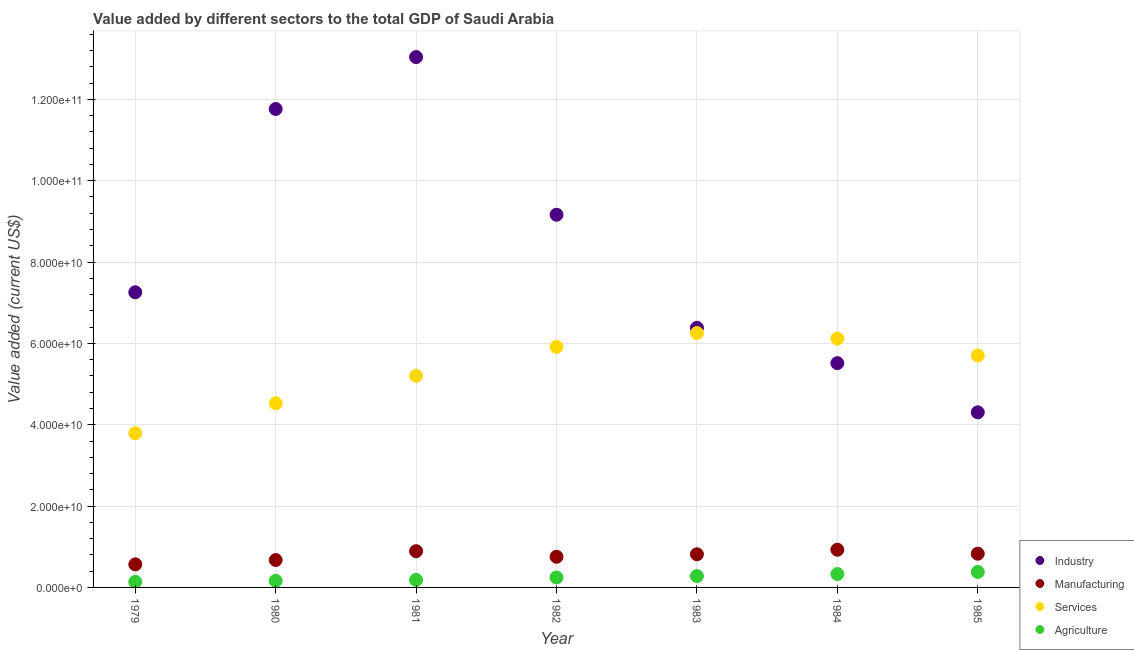What is the value added by industrial sector in 1983?
Give a very brief answer. 6.38e+1. Across all years, what is the maximum value added by industrial sector?
Keep it short and to the point. 1.30e+11. Across all years, what is the minimum value added by manufacturing sector?
Provide a succinct answer. 5.67e+09. In which year was the value added by industrial sector minimum?
Offer a very short reply. 1985. What is the total value added by industrial sector in the graph?
Your answer should be compact. 5.74e+11. What is the difference between the value added by manufacturing sector in 1984 and that in 1985?
Make the answer very short. 9.83e+08. What is the difference between the value added by services sector in 1982 and the value added by industrial sector in 1984?
Ensure brevity in your answer.  4.02e+09. What is the average value added by agricultural sector per year?
Provide a short and direct response. 2.45e+09. In the year 1982, what is the difference between the value added by manufacturing sector and value added by services sector?
Give a very brief answer. -5.16e+1. What is the ratio of the value added by agricultural sector in 1981 to that in 1983?
Keep it short and to the point. 0.66. Is the difference between the value added by manufacturing sector in 1982 and 1985 greater than the difference between the value added by industrial sector in 1982 and 1985?
Offer a terse response. No. What is the difference between the highest and the second highest value added by services sector?
Your answer should be compact. 1.36e+09. What is the difference between the highest and the lowest value added by manufacturing sector?
Make the answer very short. 3.60e+09. Is the sum of the value added by agricultural sector in 1979 and 1981 greater than the maximum value added by services sector across all years?
Your answer should be very brief. No. Is the value added by industrial sector strictly greater than the value added by manufacturing sector over the years?
Offer a terse response. Yes. Is the value added by agricultural sector strictly less than the value added by industrial sector over the years?
Your answer should be compact. Yes. How many years are there in the graph?
Offer a terse response. 7. Does the graph contain any zero values?
Ensure brevity in your answer.  No. Where does the legend appear in the graph?
Provide a short and direct response. Bottom right. How are the legend labels stacked?
Give a very brief answer. Vertical. What is the title of the graph?
Make the answer very short. Value added by different sectors to the total GDP of Saudi Arabia. Does "Ease of arranging shipments" appear as one of the legend labels in the graph?
Ensure brevity in your answer.  No. What is the label or title of the Y-axis?
Give a very brief answer. Value added (current US$). What is the Value added (current US$) of Industry in 1979?
Offer a terse response. 7.26e+1. What is the Value added (current US$) of Manufacturing in 1979?
Provide a succinct answer. 5.67e+09. What is the Value added (current US$) of Services in 1979?
Give a very brief answer. 3.79e+1. What is the Value added (current US$) of Agriculture in 1979?
Ensure brevity in your answer.  1.37e+09. What is the Value added (current US$) in Industry in 1980?
Your answer should be very brief. 1.18e+11. What is the Value added (current US$) of Manufacturing in 1980?
Offer a terse response. 6.74e+09. What is the Value added (current US$) in Services in 1980?
Your answer should be very brief. 4.53e+1. What is the Value added (current US$) of Agriculture in 1980?
Offer a terse response. 1.62e+09. What is the Value added (current US$) in Industry in 1981?
Your answer should be compact. 1.30e+11. What is the Value added (current US$) in Manufacturing in 1981?
Offer a terse response. 8.91e+09. What is the Value added (current US$) of Services in 1981?
Offer a terse response. 5.20e+1. What is the Value added (current US$) of Agriculture in 1981?
Give a very brief answer. 1.85e+09. What is the Value added (current US$) of Industry in 1982?
Keep it short and to the point. 9.16e+1. What is the Value added (current US$) in Manufacturing in 1982?
Your response must be concise. 7.54e+09. What is the Value added (current US$) in Services in 1982?
Ensure brevity in your answer.  5.92e+1. What is the Value added (current US$) of Agriculture in 1982?
Make the answer very short. 2.44e+09. What is the Value added (current US$) of Industry in 1983?
Ensure brevity in your answer.  6.38e+1. What is the Value added (current US$) of Manufacturing in 1983?
Your answer should be very brief. 8.15e+09. What is the Value added (current US$) in Services in 1983?
Your answer should be very brief. 6.25e+1. What is the Value added (current US$) in Agriculture in 1983?
Your response must be concise. 2.79e+09. What is the Value added (current US$) of Industry in 1984?
Ensure brevity in your answer.  5.51e+1. What is the Value added (current US$) of Manufacturing in 1984?
Offer a very short reply. 9.27e+09. What is the Value added (current US$) of Services in 1984?
Keep it short and to the point. 6.12e+1. What is the Value added (current US$) in Agriculture in 1984?
Provide a short and direct response. 3.30e+09. What is the Value added (current US$) in Industry in 1985?
Keep it short and to the point. 4.31e+1. What is the Value added (current US$) of Manufacturing in 1985?
Your answer should be compact. 8.29e+09. What is the Value added (current US$) in Services in 1985?
Offer a very short reply. 5.70e+1. What is the Value added (current US$) of Agriculture in 1985?
Your response must be concise. 3.81e+09. Across all years, what is the maximum Value added (current US$) of Industry?
Ensure brevity in your answer.  1.30e+11. Across all years, what is the maximum Value added (current US$) of Manufacturing?
Provide a short and direct response. 9.27e+09. Across all years, what is the maximum Value added (current US$) in Services?
Keep it short and to the point. 6.25e+1. Across all years, what is the maximum Value added (current US$) in Agriculture?
Offer a terse response. 3.81e+09. Across all years, what is the minimum Value added (current US$) of Industry?
Ensure brevity in your answer.  4.31e+1. Across all years, what is the minimum Value added (current US$) in Manufacturing?
Your answer should be very brief. 5.67e+09. Across all years, what is the minimum Value added (current US$) in Services?
Offer a terse response. 3.79e+1. Across all years, what is the minimum Value added (current US$) in Agriculture?
Make the answer very short. 1.37e+09. What is the total Value added (current US$) in Industry in the graph?
Offer a very short reply. 5.74e+11. What is the total Value added (current US$) in Manufacturing in the graph?
Your response must be concise. 5.46e+1. What is the total Value added (current US$) in Services in the graph?
Offer a very short reply. 3.75e+11. What is the total Value added (current US$) of Agriculture in the graph?
Provide a succinct answer. 1.72e+1. What is the difference between the Value added (current US$) in Industry in 1979 and that in 1980?
Provide a short and direct response. -4.51e+1. What is the difference between the Value added (current US$) of Manufacturing in 1979 and that in 1980?
Your response must be concise. -1.06e+09. What is the difference between the Value added (current US$) in Services in 1979 and that in 1980?
Offer a terse response. -7.36e+09. What is the difference between the Value added (current US$) in Agriculture in 1979 and that in 1980?
Offer a terse response. -2.54e+08. What is the difference between the Value added (current US$) of Industry in 1979 and that in 1981?
Your answer should be compact. -5.78e+1. What is the difference between the Value added (current US$) in Manufacturing in 1979 and that in 1981?
Your answer should be very brief. -3.24e+09. What is the difference between the Value added (current US$) of Services in 1979 and that in 1981?
Provide a short and direct response. -1.41e+1. What is the difference between the Value added (current US$) of Agriculture in 1979 and that in 1981?
Make the answer very short. -4.80e+08. What is the difference between the Value added (current US$) of Industry in 1979 and that in 1982?
Your answer should be compact. -1.91e+1. What is the difference between the Value added (current US$) in Manufacturing in 1979 and that in 1982?
Give a very brief answer. -1.86e+09. What is the difference between the Value added (current US$) of Services in 1979 and that in 1982?
Your answer should be very brief. -2.12e+1. What is the difference between the Value added (current US$) in Agriculture in 1979 and that in 1982?
Offer a terse response. -1.07e+09. What is the difference between the Value added (current US$) in Industry in 1979 and that in 1983?
Offer a terse response. 8.74e+09. What is the difference between the Value added (current US$) of Manufacturing in 1979 and that in 1983?
Provide a succinct answer. -2.48e+09. What is the difference between the Value added (current US$) of Services in 1979 and that in 1983?
Provide a succinct answer. -2.46e+1. What is the difference between the Value added (current US$) of Agriculture in 1979 and that in 1983?
Your answer should be compact. -1.42e+09. What is the difference between the Value added (current US$) in Industry in 1979 and that in 1984?
Provide a short and direct response. 1.74e+1. What is the difference between the Value added (current US$) of Manufacturing in 1979 and that in 1984?
Keep it short and to the point. -3.60e+09. What is the difference between the Value added (current US$) of Services in 1979 and that in 1984?
Ensure brevity in your answer.  -2.33e+1. What is the difference between the Value added (current US$) of Agriculture in 1979 and that in 1984?
Make the answer very short. -1.93e+09. What is the difference between the Value added (current US$) of Industry in 1979 and that in 1985?
Provide a short and direct response. 2.95e+1. What is the difference between the Value added (current US$) in Manufacturing in 1979 and that in 1985?
Provide a succinct answer. -2.62e+09. What is the difference between the Value added (current US$) in Services in 1979 and that in 1985?
Give a very brief answer. -1.91e+1. What is the difference between the Value added (current US$) in Agriculture in 1979 and that in 1985?
Make the answer very short. -2.44e+09. What is the difference between the Value added (current US$) of Industry in 1980 and that in 1981?
Provide a succinct answer. -1.28e+1. What is the difference between the Value added (current US$) in Manufacturing in 1980 and that in 1981?
Your answer should be compact. -2.18e+09. What is the difference between the Value added (current US$) in Services in 1980 and that in 1981?
Your answer should be very brief. -6.76e+09. What is the difference between the Value added (current US$) of Agriculture in 1980 and that in 1981?
Offer a very short reply. -2.26e+08. What is the difference between the Value added (current US$) in Industry in 1980 and that in 1982?
Provide a short and direct response. 2.60e+1. What is the difference between the Value added (current US$) in Manufacturing in 1980 and that in 1982?
Keep it short and to the point. -8.01e+08. What is the difference between the Value added (current US$) of Services in 1980 and that in 1982?
Keep it short and to the point. -1.39e+1. What is the difference between the Value added (current US$) of Agriculture in 1980 and that in 1982?
Make the answer very short. -8.19e+08. What is the difference between the Value added (current US$) in Industry in 1980 and that in 1983?
Your answer should be compact. 5.38e+1. What is the difference between the Value added (current US$) of Manufacturing in 1980 and that in 1983?
Your answer should be very brief. -1.41e+09. What is the difference between the Value added (current US$) of Services in 1980 and that in 1983?
Provide a short and direct response. -1.73e+1. What is the difference between the Value added (current US$) in Agriculture in 1980 and that in 1983?
Provide a succinct answer. -1.17e+09. What is the difference between the Value added (current US$) of Industry in 1980 and that in 1984?
Make the answer very short. 6.25e+1. What is the difference between the Value added (current US$) in Manufacturing in 1980 and that in 1984?
Your response must be concise. -2.54e+09. What is the difference between the Value added (current US$) in Services in 1980 and that in 1984?
Your answer should be compact. -1.59e+1. What is the difference between the Value added (current US$) in Agriculture in 1980 and that in 1984?
Offer a very short reply. -1.67e+09. What is the difference between the Value added (current US$) of Industry in 1980 and that in 1985?
Your answer should be very brief. 7.46e+1. What is the difference between the Value added (current US$) in Manufacturing in 1980 and that in 1985?
Offer a terse response. -1.55e+09. What is the difference between the Value added (current US$) of Services in 1980 and that in 1985?
Your response must be concise. -1.18e+1. What is the difference between the Value added (current US$) of Agriculture in 1980 and that in 1985?
Provide a short and direct response. -2.18e+09. What is the difference between the Value added (current US$) of Industry in 1981 and that in 1982?
Provide a succinct answer. 3.88e+1. What is the difference between the Value added (current US$) in Manufacturing in 1981 and that in 1982?
Your answer should be compact. 1.38e+09. What is the difference between the Value added (current US$) in Services in 1981 and that in 1982?
Your answer should be compact. -7.12e+09. What is the difference between the Value added (current US$) in Agriculture in 1981 and that in 1982?
Provide a short and direct response. -5.93e+08. What is the difference between the Value added (current US$) of Industry in 1981 and that in 1983?
Your response must be concise. 6.66e+1. What is the difference between the Value added (current US$) of Manufacturing in 1981 and that in 1983?
Give a very brief answer. 7.62e+08. What is the difference between the Value added (current US$) in Services in 1981 and that in 1983?
Offer a terse response. -1.05e+1. What is the difference between the Value added (current US$) of Agriculture in 1981 and that in 1983?
Your answer should be very brief. -9.42e+08. What is the difference between the Value added (current US$) in Industry in 1981 and that in 1984?
Provide a short and direct response. 7.53e+1. What is the difference between the Value added (current US$) of Manufacturing in 1981 and that in 1984?
Your answer should be very brief. -3.60e+08. What is the difference between the Value added (current US$) of Services in 1981 and that in 1984?
Your answer should be very brief. -9.14e+09. What is the difference between the Value added (current US$) of Agriculture in 1981 and that in 1984?
Your response must be concise. -1.45e+09. What is the difference between the Value added (current US$) of Industry in 1981 and that in 1985?
Offer a very short reply. 8.73e+1. What is the difference between the Value added (current US$) of Manufacturing in 1981 and that in 1985?
Offer a terse response. 6.23e+08. What is the difference between the Value added (current US$) in Services in 1981 and that in 1985?
Your answer should be compact. -5.00e+09. What is the difference between the Value added (current US$) in Agriculture in 1981 and that in 1985?
Offer a very short reply. -1.96e+09. What is the difference between the Value added (current US$) of Industry in 1982 and that in 1983?
Your answer should be compact. 2.78e+1. What is the difference between the Value added (current US$) in Manufacturing in 1982 and that in 1983?
Provide a succinct answer. -6.13e+08. What is the difference between the Value added (current US$) of Services in 1982 and that in 1983?
Offer a very short reply. -3.38e+09. What is the difference between the Value added (current US$) of Agriculture in 1982 and that in 1983?
Provide a short and direct response. -3.49e+08. What is the difference between the Value added (current US$) in Industry in 1982 and that in 1984?
Make the answer very short. 3.65e+1. What is the difference between the Value added (current US$) of Manufacturing in 1982 and that in 1984?
Keep it short and to the point. -1.74e+09. What is the difference between the Value added (current US$) in Services in 1982 and that in 1984?
Ensure brevity in your answer.  -2.02e+09. What is the difference between the Value added (current US$) of Agriculture in 1982 and that in 1984?
Offer a terse response. -8.55e+08. What is the difference between the Value added (current US$) in Industry in 1982 and that in 1985?
Provide a succinct answer. 4.86e+1. What is the difference between the Value added (current US$) in Manufacturing in 1982 and that in 1985?
Provide a short and direct response. -7.53e+08. What is the difference between the Value added (current US$) of Services in 1982 and that in 1985?
Make the answer very short. 2.13e+09. What is the difference between the Value added (current US$) of Agriculture in 1982 and that in 1985?
Your answer should be very brief. -1.36e+09. What is the difference between the Value added (current US$) of Industry in 1983 and that in 1984?
Your answer should be very brief. 8.69e+09. What is the difference between the Value added (current US$) of Manufacturing in 1983 and that in 1984?
Offer a terse response. -1.12e+09. What is the difference between the Value added (current US$) in Services in 1983 and that in 1984?
Provide a succinct answer. 1.36e+09. What is the difference between the Value added (current US$) in Agriculture in 1983 and that in 1984?
Your response must be concise. -5.06e+08. What is the difference between the Value added (current US$) in Industry in 1983 and that in 1985?
Provide a succinct answer. 2.08e+1. What is the difference between the Value added (current US$) of Manufacturing in 1983 and that in 1985?
Provide a short and direct response. -1.40e+08. What is the difference between the Value added (current US$) of Services in 1983 and that in 1985?
Give a very brief answer. 5.51e+09. What is the difference between the Value added (current US$) in Agriculture in 1983 and that in 1985?
Offer a terse response. -1.02e+09. What is the difference between the Value added (current US$) of Industry in 1984 and that in 1985?
Make the answer very short. 1.21e+1. What is the difference between the Value added (current US$) of Manufacturing in 1984 and that in 1985?
Offer a terse response. 9.83e+08. What is the difference between the Value added (current US$) of Services in 1984 and that in 1985?
Your answer should be very brief. 4.14e+09. What is the difference between the Value added (current US$) of Agriculture in 1984 and that in 1985?
Make the answer very short. -5.10e+08. What is the difference between the Value added (current US$) of Industry in 1979 and the Value added (current US$) of Manufacturing in 1980?
Provide a succinct answer. 6.58e+1. What is the difference between the Value added (current US$) in Industry in 1979 and the Value added (current US$) in Services in 1980?
Your response must be concise. 2.73e+1. What is the difference between the Value added (current US$) of Industry in 1979 and the Value added (current US$) of Agriculture in 1980?
Your answer should be compact. 7.10e+1. What is the difference between the Value added (current US$) of Manufacturing in 1979 and the Value added (current US$) of Services in 1980?
Provide a short and direct response. -3.96e+1. What is the difference between the Value added (current US$) in Manufacturing in 1979 and the Value added (current US$) in Agriculture in 1980?
Your answer should be compact. 4.05e+09. What is the difference between the Value added (current US$) of Services in 1979 and the Value added (current US$) of Agriculture in 1980?
Your response must be concise. 3.63e+1. What is the difference between the Value added (current US$) in Industry in 1979 and the Value added (current US$) in Manufacturing in 1981?
Provide a succinct answer. 6.37e+1. What is the difference between the Value added (current US$) in Industry in 1979 and the Value added (current US$) in Services in 1981?
Keep it short and to the point. 2.05e+1. What is the difference between the Value added (current US$) of Industry in 1979 and the Value added (current US$) of Agriculture in 1981?
Offer a very short reply. 7.07e+1. What is the difference between the Value added (current US$) of Manufacturing in 1979 and the Value added (current US$) of Services in 1981?
Keep it short and to the point. -4.64e+1. What is the difference between the Value added (current US$) of Manufacturing in 1979 and the Value added (current US$) of Agriculture in 1981?
Provide a short and direct response. 3.82e+09. What is the difference between the Value added (current US$) of Services in 1979 and the Value added (current US$) of Agriculture in 1981?
Offer a terse response. 3.61e+1. What is the difference between the Value added (current US$) in Industry in 1979 and the Value added (current US$) in Manufacturing in 1982?
Keep it short and to the point. 6.50e+1. What is the difference between the Value added (current US$) in Industry in 1979 and the Value added (current US$) in Services in 1982?
Your response must be concise. 1.34e+1. What is the difference between the Value added (current US$) in Industry in 1979 and the Value added (current US$) in Agriculture in 1982?
Make the answer very short. 7.01e+1. What is the difference between the Value added (current US$) in Manufacturing in 1979 and the Value added (current US$) in Services in 1982?
Offer a very short reply. -5.35e+1. What is the difference between the Value added (current US$) in Manufacturing in 1979 and the Value added (current US$) in Agriculture in 1982?
Make the answer very short. 3.23e+09. What is the difference between the Value added (current US$) in Services in 1979 and the Value added (current US$) in Agriculture in 1982?
Offer a very short reply. 3.55e+1. What is the difference between the Value added (current US$) of Industry in 1979 and the Value added (current US$) of Manufacturing in 1983?
Offer a very short reply. 6.44e+1. What is the difference between the Value added (current US$) in Industry in 1979 and the Value added (current US$) in Services in 1983?
Offer a terse response. 1.00e+1. What is the difference between the Value added (current US$) of Industry in 1979 and the Value added (current US$) of Agriculture in 1983?
Ensure brevity in your answer.  6.98e+1. What is the difference between the Value added (current US$) in Manufacturing in 1979 and the Value added (current US$) in Services in 1983?
Keep it short and to the point. -5.69e+1. What is the difference between the Value added (current US$) in Manufacturing in 1979 and the Value added (current US$) in Agriculture in 1983?
Your answer should be very brief. 2.88e+09. What is the difference between the Value added (current US$) in Services in 1979 and the Value added (current US$) in Agriculture in 1983?
Provide a short and direct response. 3.51e+1. What is the difference between the Value added (current US$) of Industry in 1979 and the Value added (current US$) of Manufacturing in 1984?
Your answer should be compact. 6.33e+1. What is the difference between the Value added (current US$) in Industry in 1979 and the Value added (current US$) in Services in 1984?
Offer a very short reply. 1.14e+1. What is the difference between the Value added (current US$) of Industry in 1979 and the Value added (current US$) of Agriculture in 1984?
Ensure brevity in your answer.  6.93e+1. What is the difference between the Value added (current US$) of Manufacturing in 1979 and the Value added (current US$) of Services in 1984?
Keep it short and to the point. -5.55e+1. What is the difference between the Value added (current US$) of Manufacturing in 1979 and the Value added (current US$) of Agriculture in 1984?
Ensure brevity in your answer.  2.38e+09. What is the difference between the Value added (current US$) of Services in 1979 and the Value added (current US$) of Agriculture in 1984?
Give a very brief answer. 3.46e+1. What is the difference between the Value added (current US$) of Industry in 1979 and the Value added (current US$) of Manufacturing in 1985?
Keep it short and to the point. 6.43e+1. What is the difference between the Value added (current US$) of Industry in 1979 and the Value added (current US$) of Services in 1985?
Provide a short and direct response. 1.55e+1. What is the difference between the Value added (current US$) in Industry in 1979 and the Value added (current US$) in Agriculture in 1985?
Offer a terse response. 6.88e+1. What is the difference between the Value added (current US$) of Manufacturing in 1979 and the Value added (current US$) of Services in 1985?
Ensure brevity in your answer.  -5.14e+1. What is the difference between the Value added (current US$) of Manufacturing in 1979 and the Value added (current US$) of Agriculture in 1985?
Your answer should be very brief. 1.87e+09. What is the difference between the Value added (current US$) of Services in 1979 and the Value added (current US$) of Agriculture in 1985?
Your response must be concise. 3.41e+1. What is the difference between the Value added (current US$) of Industry in 1980 and the Value added (current US$) of Manufacturing in 1981?
Offer a terse response. 1.09e+11. What is the difference between the Value added (current US$) in Industry in 1980 and the Value added (current US$) in Services in 1981?
Your answer should be compact. 6.56e+1. What is the difference between the Value added (current US$) in Industry in 1980 and the Value added (current US$) in Agriculture in 1981?
Your response must be concise. 1.16e+11. What is the difference between the Value added (current US$) in Manufacturing in 1980 and the Value added (current US$) in Services in 1981?
Make the answer very short. -4.53e+1. What is the difference between the Value added (current US$) in Manufacturing in 1980 and the Value added (current US$) in Agriculture in 1981?
Give a very brief answer. 4.89e+09. What is the difference between the Value added (current US$) in Services in 1980 and the Value added (current US$) in Agriculture in 1981?
Provide a short and direct response. 4.34e+1. What is the difference between the Value added (current US$) of Industry in 1980 and the Value added (current US$) of Manufacturing in 1982?
Keep it short and to the point. 1.10e+11. What is the difference between the Value added (current US$) in Industry in 1980 and the Value added (current US$) in Services in 1982?
Your answer should be compact. 5.85e+1. What is the difference between the Value added (current US$) of Industry in 1980 and the Value added (current US$) of Agriculture in 1982?
Offer a terse response. 1.15e+11. What is the difference between the Value added (current US$) of Manufacturing in 1980 and the Value added (current US$) of Services in 1982?
Provide a succinct answer. -5.24e+1. What is the difference between the Value added (current US$) of Manufacturing in 1980 and the Value added (current US$) of Agriculture in 1982?
Your answer should be very brief. 4.29e+09. What is the difference between the Value added (current US$) of Services in 1980 and the Value added (current US$) of Agriculture in 1982?
Your response must be concise. 4.28e+1. What is the difference between the Value added (current US$) of Industry in 1980 and the Value added (current US$) of Manufacturing in 1983?
Your answer should be compact. 1.09e+11. What is the difference between the Value added (current US$) in Industry in 1980 and the Value added (current US$) in Services in 1983?
Your response must be concise. 5.51e+1. What is the difference between the Value added (current US$) in Industry in 1980 and the Value added (current US$) in Agriculture in 1983?
Offer a very short reply. 1.15e+11. What is the difference between the Value added (current US$) in Manufacturing in 1980 and the Value added (current US$) in Services in 1983?
Make the answer very short. -5.58e+1. What is the difference between the Value added (current US$) in Manufacturing in 1980 and the Value added (current US$) in Agriculture in 1983?
Give a very brief answer. 3.95e+09. What is the difference between the Value added (current US$) of Services in 1980 and the Value added (current US$) of Agriculture in 1983?
Provide a short and direct response. 4.25e+1. What is the difference between the Value added (current US$) of Industry in 1980 and the Value added (current US$) of Manufacturing in 1984?
Provide a succinct answer. 1.08e+11. What is the difference between the Value added (current US$) in Industry in 1980 and the Value added (current US$) in Services in 1984?
Provide a succinct answer. 5.65e+1. What is the difference between the Value added (current US$) of Industry in 1980 and the Value added (current US$) of Agriculture in 1984?
Offer a very short reply. 1.14e+11. What is the difference between the Value added (current US$) of Manufacturing in 1980 and the Value added (current US$) of Services in 1984?
Keep it short and to the point. -5.44e+1. What is the difference between the Value added (current US$) in Manufacturing in 1980 and the Value added (current US$) in Agriculture in 1984?
Your answer should be very brief. 3.44e+09. What is the difference between the Value added (current US$) in Services in 1980 and the Value added (current US$) in Agriculture in 1984?
Provide a succinct answer. 4.20e+1. What is the difference between the Value added (current US$) of Industry in 1980 and the Value added (current US$) of Manufacturing in 1985?
Your response must be concise. 1.09e+11. What is the difference between the Value added (current US$) in Industry in 1980 and the Value added (current US$) in Services in 1985?
Give a very brief answer. 6.06e+1. What is the difference between the Value added (current US$) of Industry in 1980 and the Value added (current US$) of Agriculture in 1985?
Give a very brief answer. 1.14e+11. What is the difference between the Value added (current US$) of Manufacturing in 1980 and the Value added (current US$) of Services in 1985?
Offer a very short reply. -5.03e+1. What is the difference between the Value added (current US$) of Manufacturing in 1980 and the Value added (current US$) of Agriculture in 1985?
Keep it short and to the point. 2.93e+09. What is the difference between the Value added (current US$) in Services in 1980 and the Value added (current US$) in Agriculture in 1985?
Offer a terse response. 4.15e+1. What is the difference between the Value added (current US$) in Industry in 1981 and the Value added (current US$) in Manufacturing in 1982?
Your response must be concise. 1.23e+11. What is the difference between the Value added (current US$) of Industry in 1981 and the Value added (current US$) of Services in 1982?
Your answer should be very brief. 7.12e+1. What is the difference between the Value added (current US$) in Industry in 1981 and the Value added (current US$) in Agriculture in 1982?
Your answer should be compact. 1.28e+11. What is the difference between the Value added (current US$) in Manufacturing in 1981 and the Value added (current US$) in Services in 1982?
Provide a succinct answer. -5.02e+1. What is the difference between the Value added (current US$) in Manufacturing in 1981 and the Value added (current US$) in Agriculture in 1982?
Provide a succinct answer. 6.47e+09. What is the difference between the Value added (current US$) of Services in 1981 and the Value added (current US$) of Agriculture in 1982?
Make the answer very short. 4.96e+1. What is the difference between the Value added (current US$) of Industry in 1981 and the Value added (current US$) of Manufacturing in 1983?
Your response must be concise. 1.22e+11. What is the difference between the Value added (current US$) of Industry in 1981 and the Value added (current US$) of Services in 1983?
Ensure brevity in your answer.  6.79e+1. What is the difference between the Value added (current US$) in Industry in 1981 and the Value added (current US$) in Agriculture in 1983?
Give a very brief answer. 1.28e+11. What is the difference between the Value added (current US$) in Manufacturing in 1981 and the Value added (current US$) in Services in 1983?
Keep it short and to the point. -5.36e+1. What is the difference between the Value added (current US$) in Manufacturing in 1981 and the Value added (current US$) in Agriculture in 1983?
Offer a very short reply. 6.12e+09. What is the difference between the Value added (current US$) in Services in 1981 and the Value added (current US$) in Agriculture in 1983?
Provide a succinct answer. 4.92e+1. What is the difference between the Value added (current US$) of Industry in 1981 and the Value added (current US$) of Manufacturing in 1984?
Give a very brief answer. 1.21e+11. What is the difference between the Value added (current US$) in Industry in 1981 and the Value added (current US$) in Services in 1984?
Your response must be concise. 6.92e+1. What is the difference between the Value added (current US$) of Industry in 1981 and the Value added (current US$) of Agriculture in 1984?
Your response must be concise. 1.27e+11. What is the difference between the Value added (current US$) in Manufacturing in 1981 and the Value added (current US$) in Services in 1984?
Your answer should be compact. -5.23e+1. What is the difference between the Value added (current US$) in Manufacturing in 1981 and the Value added (current US$) in Agriculture in 1984?
Offer a very short reply. 5.62e+09. What is the difference between the Value added (current US$) in Services in 1981 and the Value added (current US$) in Agriculture in 1984?
Give a very brief answer. 4.87e+1. What is the difference between the Value added (current US$) of Industry in 1981 and the Value added (current US$) of Manufacturing in 1985?
Keep it short and to the point. 1.22e+11. What is the difference between the Value added (current US$) of Industry in 1981 and the Value added (current US$) of Services in 1985?
Provide a short and direct response. 7.34e+1. What is the difference between the Value added (current US$) in Industry in 1981 and the Value added (current US$) in Agriculture in 1985?
Keep it short and to the point. 1.27e+11. What is the difference between the Value added (current US$) in Manufacturing in 1981 and the Value added (current US$) in Services in 1985?
Your answer should be compact. -4.81e+1. What is the difference between the Value added (current US$) in Manufacturing in 1981 and the Value added (current US$) in Agriculture in 1985?
Offer a very short reply. 5.11e+09. What is the difference between the Value added (current US$) of Services in 1981 and the Value added (current US$) of Agriculture in 1985?
Offer a very short reply. 4.82e+1. What is the difference between the Value added (current US$) of Industry in 1982 and the Value added (current US$) of Manufacturing in 1983?
Make the answer very short. 8.35e+1. What is the difference between the Value added (current US$) in Industry in 1982 and the Value added (current US$) in Services in 1983?
Make the answer very short. 2.91e+1. What is the difference between the Value added (current US$) of Industry in 1982 and the Value added (current US$) of Agriculture in 1983?
Offer a very short reply. 8.88e+1. What is the difference between the Value added (current US$) in Manufacturing in 1982 and the Value added (current US$) in Services in 1983?
Offer a terse response. -5.50e+1. What is the difference between the Value added (current US$) of Manufacturing in 1982 and the Value added (current US$) of Agriculture in 1983?
Your response must be concise. 4.75e+09. What is the difference between the Value added (current US$) of Services in 1982 and the Value added (current US$) of Agriculture in 1983?
Give a very brief answer. 5.64e+1. What is the difference between the Value added (current US$) of Industry in 1982 and the Value added (current US$) of Manufacturing in 1984?
Provide a short and direct response. 8.24e+1. What is the difference between the Value added (current US$) in Industry in 1982 and the Value added (current US$) in Services in 1984?
Make the answer very short. 3.05e+1. What is the difference between the Value added (current US$) in Industry in 1982 and the Value added (current US$) in Agriculture in 1984?
Provide a short and direct response. 8.83e+1. What is the difference between the Value added (current US$) of Manufacturing in 1982 and the Value added (current US$) of Services in 1984?
Provide a short and direct response. -5.36e+1. What is the difference between the Value added (current US$) in Manufacturing in 1982 and the Value added (current US$) in Agriculture in 1984?
Offer a very short reply. 4.24e+09. What is the difference between the Value added (current US$) of Services in 1982 and the Value added (current US$) of Agriculture in 1984?
Ensure brevity in your answer.  5.59e+1. What is the difference between the Value added (current US$) in Industry in 1982 and the Value added (current US$) in Manufacturing in 1985?
Offer a terse response. 8.33e+1. What is the difference between the Value added (current US$) of Industry in 1982 and the Value added (current US$) of Services in 1985?
Offer a very short reply. 3.46e+1. What is the difference between the Value added (current US$) in Industry in 1982 and the Value added (current US$) in Agriculture in 1985?
Provide a short and direct response. 8.78e+1. What is the difference between the Value added (current US$) in Manufacturing in 1982 and the Value added (current US$) in Services in 1985?
Keep it short and to the point. -4.95e+1. What is the difference between the Value added (current US$) in Manufacturing in 1982 and the Value added (current US$) in Agriculture in 1985?
Provide a succinct answer. 3.73e+09. What is the difference between the Value added (current US$) in Services in 1982 and the Value added (current US$) in Agriculture in 1985?
Provide a succinct answer. 5.54e+1. What is the difference between the Value added (current US$) in Industry in 1983 and the Value added (current US$) in Manufacturing in 1984?
Ensure brevity in your answer.  5.46e+1. What is the difference between the Value added (current US$) of Industry in 1983 and the Value added (current US$) of Services in 1984?
Offer a very short reply. 2.66e+09. What is the difference between the Value added (current US$) in Industry in 1983 and the Value added (current US$) in Agriculture in 1984?
Your answer should be compact. 6.05e+1. What is the difference between the Value added (current US$) in Manufacturing in 1983 and the Value added (current US$) in Services in 1984?
Your answer should be very brief. -5.30e+1. What is the difference between the Value added (current US$) in Manufacturing in 1983 and the Value added (current US$) in Agriculture in 1984?
Offer a terse response. 4.85e+09. What is the difference between the Value added (current US$) in Services in 1983 and the Value added (current US$) in Agriculture in 1984?
Offer a very short reply. 5.92e+1. What is the difference between the Value added (current US$) of Industry in 1983 and the Value added (current US$) of Manufacturing in 1985?
Provide a succinct answer. 5.55e+1. What is the difference between the Value added (current US$) in Industry in 1983 and the Value added (current US$) in Services in 1985?
Ensure brevity in your answer.  6.80e+09. What is the difference between the Value added (current US$) in Industry in 1983 and the Value added (current US$) in Agriculture in 1985?
Ensure brevity in your answer.  6.00e+1. What is the difference between the Value added (current US$) of Manufacturing in 1983 and the Value added (current US$) of Services in 1985?
Provide a succinct answer. -4.89e+1. What is the difference between the Value added (current US$) in Manufacturing in 1983 and the Value added (current US$) in Agriculture in 1985?
Make the answer very short. 4.34e+09. What is the difference between the Value added (current US$) in Services in 1983 and the Value added (current US$) in Agriculture in 1985?
Provide a succinct answer. 5.87e+1. What is the difference between the Value added (current US$) in Industry in 1984 and the Value added (current US$) in Manufacturing in 1985?
Provide a succinct answer. 4.69e+1. What is the difference between the Value added (current US$) in Industry in 1984 and the Value added (current US$) in Services in 1985?
Offer a very short reply. -1.89e+09. What is the difference between the Value added (current US$) of Industry in 1984 and the Value added (current US$) of Agriculture in 1985?
Ensure brevity in your answer.  5.13e+1. What is the difference between the Value added (current US$) in Manufacturing in 1984 and the Value added (current US$) in Services in 1985?
Ensure brevity in your answer.  -4.78e+1. What is the difference between the Value added (current US$) of Manufacturing in 1984 and the Value added (current US$) of Agriculture in 1985?
Your response must be concise. 5.47e+09. What is the difference between the Value added (current US$) of Services in 1984 and the Value added (current US$) of Agriculture in 1985?
Your answer should be compact. 5.74e+1. What is the average Value added (current US$) of Industry per year?
Offer a terse response. 8.20e+1. What is the average Value added (current US$) of Manufacturing per year?
Provide a succinct answer. 7.80e+09. What is the average Value added (current US$) in Services per year?
Offer a terse response. 5.36e+1. What is the average Value added (current US$) of Agriculture per year?
Provide a short and direct response. 2.45e+09. In the year 1979, what is the difference between the Value added (current US$) of Industry and Value added (current US$) of Manufacturing?
Your response must be concise. 6.69e+1. In the year 1979, what is the difference between the Value added (current US$) in Industry and Value added (current US$) in Services?
Provide a succinct answer. 3.47e+1. In the year 1979, what is the difference between the Value added (current US$) in Industry and Value added (current US$) in Agriculture?
Your answer should be very brief. 7.12e+1. In the year 1979, what is the difference between the Value added (current US$) in Manufacturing and Value added (current US$) in Services?
Offer a very short reply. -3.22e+1. In the year 1979, what is the difference between the Value added (current US$) in Manufacturing and Value added (current US$) in Agriculture?
Provide a succinct answer. 4.30e+09. In the year 1979, what is the difference between the Value added (current US$) of Services and Value added (current US$) of Agriculture?
Offer a terse response. 3.65e+1. In the year 1980, what is the difference between the Value added (current US$) in Industry and Value added (current US$) in Manufacturing?
Offer a very short reply. 1.11e+11. In the year 1980, what is the difference between the Value added (current US$) in Industry and Value added (current US$) in Services?
Your answer should be compact. 7.24e+1. In the year 1980, what is the difference between the Value added (current US$) of Industry and Value added (current US$) of Agriculture?
Provide a short and direct response. 1.16e+11. In the year 1980, what is the difference between the Value added (current US$) in Manufacturing and Value added (current US$) in Services?
Ensure brevity in your answer.  -3.85e+1. In the year 1980, what is the difference between the Value added (current US$) in Manufacturing and Value added (current US$) in Agriculture?
Keep it short and to the point. 5.11e+09. In the year 1980, what is the difference between the Value added (current US$) of Services and Value added (current US$) of Agriculture?
Your answer should be very brief. 4.37e+1. In the year 1981, what is the difference between the Value added (current US$) of Industry and Value added (current US$) of Manufacturing?
Provide a succinct answer. 1.21e+11. In the year 1981, what is the difference between the Value added (current US$) in Industry and Value added (current US$) in Services?
Ensure brevity in your answer.  7.84e+1. In the year 1981, what is the difference between the Value added (current US$) in Industry and Value added (current US$) in Agriculture?
Ensure brevity in your answer.  1.29e+11. In the year 1981, what is the difference between the Value added (current US$) of Manufacturing and Value added (current US$) of Services?
Ensure brevity in your answer.  -4.31e+1. In the year 1981, what is the difference between the Value added (current US$) in Manufacturing and Value added (current US$) in Agriculture?
Your answer should be compact. 7.06e+09. In the year 1981, what is the difference between the Value added (current US$) of Services and Value added (current US$) of Agriculture?
Your answer should be very brief. 5.02e+1. In the year 1982, what is the difference between the Value added (current US$) of Industry and Value added (current US$) of Manufacturing?
Provide a succinct answer. 8.41e+1. In the year 1982, what is the difference between the Value added (current US$) of Industry and Value added (current US$) of Services?
Offer a terse response. 3.25e+1. In the year 1982, what is the difference between the Value added (current US$) in Industry and Value added (current US$) in Agriculture?
Offer a very short reply. 8.92e+1. In the year 1982, what is the difference between the Value added (current US$) of Manufacturing and Value added (current US$) of Services?
Give a very brief answer. -5.16e+1. In the year 1982, what is the difference between the Value added (current US$) in Manufacturing and Value added (current US$) in Agriculture?
Provide a succinct answer. 5.10e+09. In the year 1982, what is the difference between the Value added (current US$) in Services and Value added (current US$) in Agriculture?
Give a very brief answer. 5.67e+1. In the year 1983, what is the difference between the Value added (current US$) of Industry and Value added (current US$) of Manufacturing?
Your answer should be compact. 5.57e+1. In the year 1983, what is the difference between the Value added (current US$) of Industry and Value added (current US$) of Services?
Your response must be concise. 1.30e+09. In the year 1983, what is the difference between the Value added (current US$) of Industry and Value added (current US$) of Agriculture?
Keep it short and to the point. 6.10e+1. In the year 1983, what is the difference between the Value added (current US$) in Manufacturing and Value added (current US$) in Services?
Offer a very short reply. -5.44e+1. In the year 1983, what is the difference between the Value added (current US$) in Manufacturing and Value added (current US$) in Agriculture?
Give a very brief answer. 5.36e+09. In the year 1983, what is the difference between the Value added (current US$) of Services and Value added (current US$) of Agriculture?
Your answer should be very brief. 5.98e+1. In the year 1984, what is the difference between the Value added (current US$) of Industry and Value added (current US$) of Manufacturing?
Provide a succinct answer. 4.59e+1. In the year 1984, what is the difference between the Value added (current US$) of Industry and Value added (current US$) of Services?
Provide a succinct answer. -6.04e+09. In the year 1984, what is the difference between the Value added (current US$) of Industry and Value added (current US$) of Agriculture?
Ensure brevity in your answer.  5.18e+1. In the year 1984, what is the difference between the Value added (current US$) in Manufacturing and Value added (current US$) in Services?
Your answer should be compact. -5.19e+1. In the year 1984, what is the difference between the Value added (current US$) in Manufacturing and Value added (current US$) in Agriculture?
Your answer should be compact. 5.98e+09. In the year 1984, what is the difference between the Value added (current US$) in Services and Value added (current US$) in Agriculture?
Provide a short and direct response. 5.79e+1. In the year 1985, what is the difference between the Value added (current US$) in Industry and Value added (current US$) in Manufacturing?
Provide a short and direct response. 3.48e+1. In the year 1985, what is the difference between the Value added (current US$) in Industry and Value added (current US$) in Services?
Make the answer very short. -1.40e+1. In the year 1985, what is the difference between the Value added (current US$) in Industry and Value added (current US$) in Agriculture?
Your response must be concise. 3.92e+1. In the year 1985, what is the difference between the Value added (current US$) in Manufacturing and Value added (current US$) in Services?
Provide a short and direct response. -4.87e+1. In the year 1985, what is the difference between the Value added (current US$) of Manufacturing and Value added (current US$) of Agriculture?
Give a very brief answer. 4.48e+09. In the year 1985, what is the difference between the Value added (current US$) of Services and Value added (current US$) of Agriculture?
Your answer should be very brief. 5.32e+1. What is the ratio of the Value added (current US$) of Industry in 1979 to that in 1980?
Provide a short and direct response. 0.62. What is the ratio of the Value added (current US$) in Manufacturing in 1979 to that in 1980?
Provide a short and direct response. 0.84. What is the ratio of the Value added (current US$) of Services in 1979 to that in 1980?
Your answer should be compact. 0.84. What is the ratio of the Value added (current US$) in Agriculture in 1979 to that in 1980?
Offer a very short reply. 0.84. What is the ratio of the Value added (current US$) of Industry in 1979 to that in 1981?
Ensure brevity in your answer.  0.56. What is the ratio of the Value added (current US$) in Manufacturing in 1979 to that in 1981?
Your response must be concise. 0.64. What is the ratio of the Value added (current US$) in Services in 1979 to that in 1981?
Give a very brief answer. 0.73. What is the ratio of the Value added (current US$) in Agriculture in 1979 to that in 1981?
Your answer should be compact. 0.74. What is the ratio of the Value added (current US$) in Industry in 1979 to that in 1982?
Provide a short and direct response. 0.79. What is the ratio of the Value added (current US$) of Manufacturing in 1979 to that in 1982?
Your response must be concise. 0.75. What is the ratio of the Value added (current US$) of Services in 1979 to that in 1982?
Make the answer very short. 0.64. What is the ratio of the Value added (current US$) of Agriculture in 1979 to that in 1982?
Make the answer very short. 0.56. What is the ratio of the Value added (current US$) in Industry in 1979 to that in 1983?
Offer a terse response. 1.14. What is the ratio of the Value added (current US$) in Manufacturing in 1979 to that in 1983?
Your answer should be very brief. 0.7. What is the ratio of the Value added (current US$) of Services in 1979 to that in 1983?
Your response must be concise. 0.61. What is the ratio of the Value added (current US$) in Agriculture in 1979 to that in 1983?
Your answer should be compact. 0.49. What is the ratio of the Value added (current US$) of Industry in 1979 to that in 1984?
Provide a short and direct response. 1.32. What is the ratio of the Value added (current US$) in Manufacturing in 1979 to that in 1984?
Give a very brief answer. 0.61. What is the ratio of the Value added (current US$) of Services in 1979 to that in 1984?
Offer a very short reply. 0.62. What is the ratio of the Value added (current US$) of Agriculture in 1979 to that in 1984?
Offer a terse response. 0.42. What is the ratio of the Value added (current US$) of Industry in 1979 to that in 1985?
Ensure brevity in your answer.  1.69. What is the ratio of the Value added (current US$) in Manufacturing in 1979 to that in 1985?
Ensure brevity in your answer.  0.68. What is the ratio of the Value added (current US$) in Services in 1979 to that in 1985?
Provide a succinct answer. 0.66. What is the ratio of the Value added (current US$) of Agriculture in 1979 to that in 1985?
Make the answer very short. 0.36. What is the ratio of the Value added (current US$) of Industry in 1980 to that in 1981?
Your answer should be compact. 0.9. What is the ratio of the Value added (current US$) in Manufacturing in 1980 to that in 1981?
Offer a very short reply. 0.76. What is the ratio of the Value added (current US$) in Services in 1980 to that in 1981?
Your answer should be very brief. 0.87. What is the ratio of the Value added (current US$) of Agriculture in 1980 to that in 1981?
Ensure brevity in your answer.  0.88. What is the ratio of the Value added (current US$) of Industry in 1980 to that in 1982?
Provide a short and direct response. 1.28. What is the ratio of the Value added (current US$) in Manufacturing in 1980 to that in 1982?
Provide a short and direct response. 0.89. What is the ratio of the Value added (current US$) in Services in 1980 to that in 1982?
Give a very brief answer. 0.77. What is the ratio of the Value added (current US$) in Agriculture in 1980 to that in 1982?
Ensure brevity in your answer.  0.66. What is the ratio of the Value added (current US$) of Industry in 1980 to that in 1983?
Ensure brevity in your answer.  1.84. What is the ratio of the Value added (current US$) of Manufacturing in 1980 to that in 1983?
Keep it short and to the point. 0.83. What is the ratio of the Value added (current US$) in Services in 1980 to that in 1983?
Give a very brief answer. 0.72. What is the ratio of the Value added (current US$) in Agriculture in 1980 to that in 1983?
Keep it short and to the point. 0.58. What is the ratio of the Value added (current US$) of Industry in 1980 to that in 1984?
Provide a succinct answer. 2.13. What is the ratio of the Value added (current US$) of Manufacturing in 1980 to that in 1984?
Ensure brevity in your answer.  0.73. What is the ratio of the Value added (current US$) of Services in 1980 to that in 1984?
Keep it short and to the point. 0.74. What is the ratio of the Value added (current US$) of Agriculture in 1980 to that in 1984?
Make the answer very short. 0.49. What is the ratio of the Value added (current US$) of Industry in 1980 to that in 1985?
Your answer should be compact. 2.73. What is the ratio of the Value added (current US$) in Manufacturing in 1980 to that in 1985?
Offer a terse response. 0.81. What is the ratio of the Value added (current US$) of Services in 1980 to that in 1985?
Your answer should be compact. 0.79. What is the ratio of the Value added (current US$) in Agriculture in 1980 to that in 1985?
Provide a short and direct response. 0.43. What is the ratio of the Value added (current US$) of Industry in 1981 to that in 1982?
Your answer should be very brief. 1.42. What is the ratio of the Value added (current US$) of Manufacturing in 1981 to that in 1982?
Your answer should be compact. 1.18. What is the ratio of the Value added (current US$) in Services in 1981 to that in 1982?
Your answer should be compact. 0.88. What is the ratio of the Value added (current US$) of Agriculture in 1981 to that in 1982?
Your response must be concise. 0.76. What is the ratio of the Value added (current US$) of Industry in 1981 to that in 1983?
Make the answer very short. 2.04. What is the ratio of the Value added (current US$) in Manufacturing in 1981 to that in 1983?
Ensure brevity in your answer.  1.09. What is the ratio of the Value added (current US$) in Services in 1981 to that in 1983?
Offer a very short reply. 0.83. What is the ratio of the Value added (current US$) of Agriculture in 1981 to that in 1983?
Offer a terse response. 0.66. What is the ratio of the Value added (current US$) in Industry in 1981 to that in 1984?
Offer a terse response. 2.36. What is the ratio of the Value added (current US$) of Manufacturing in 1981 to that in 1984?
Ensure brevity in your answer.  0.96. What is the ratio of the Value added (current US$) of Services in 1981 to that in 1984?
Your response must be concise. 0.85. What is the ratio of the Value added (current US$) of Agriculture in 1981 to that in 1984?
Keep it short and to the point. 0.56. What is the ratio of the Value added (current US$) in Industry in 1981 to that in 1985?
Give a very brief answer. 3.03. What is the ratio of the Value added (current US$) of Manufacturing in 1981 to that in 1985?
Your answer should be compact. 1.08. What is the ratio of the Value added (current US$) in Services in 1981 to that in 1985?
Make the answer very short. 0.91. What is the ratio of the Value added (current US$) in Agriculture in 1981 to that in 1985?
Ensure brevity in your answer.  0.49. What is the ratio of the Value added (current US$) of Industry in 1982 to that in 1983?
Your answer should be very brief. 1.44. What is the ratio of the Value added (current US$) in Manufacturing in 1982 to that in 1983?
Provide a short and direct response. 0.92. What is the ratio of the Value added (current US$) of Services in 1982 to that in 1983?
Provide a succinct answer. 0.95. What is the ratio of the Value added (current US$) of Agriculture in 1982 to that in 1983?
Provide a succinct answer. 0.88. What is the ratio of the Value added (current US$) of Industry in 1982 to that in 1984?
Make the answer very short. 1.66. What is the ratio of the Value added (current US$) in Manufacturing in 1982 to that in 1984?
Your answer should be very brief. 0.81. What is the ratio of the Value added (current US$) in Agriculture in 1982 to that in 1984?
Ensure brevity in your answer.  0.74. What is the ratio of the Value added (current US$) of Industry in 1982 to that in 1985?
Provide a succinct answer. 2.13. What is the ratio of the Value added (current US$) of Manufacturing in 1982 to that in 1985?
Keep it short and to the point. 0.91. What is the ratio of the Value added (current US$) of Services in 1982 to that in 1985?
Provide a succinct answer. 1.04. What is the ratio of the Value added (current US$) in Agriculture in 1982 to that in 1985?
Provide a succinct answer. 0.64. What is the ratio of the Value added (current US$) of Industry in 1983 to that in 1984?
Your answer should be compact. 1.16. What is the ratio of the Value added (current US$) in Manufacturing in 1983 to that in 1984?
Offer a very short reply. 0.88. What is the ratio of the Value added (current US$) in Services in 1983 to that in 1984?
Offer a terse response. 1.02. What is the ratio of the Value added (current US$) of Agriculture in 1983 to that in 1984?
Provide a short and direct response. 0.85. What is the ratio of the Value added (current US$) in Industry in 1983 to that in 1985?
Provide a short and direct response. 1.48. What is the ratio of the Value added (current US$) in Manufacturing in 1983 to that in 1985?
Give a very brief answer. 0.98. What is the ratio of the Value added (current US$) of Services in 1983 to that in 1985?
Your answer should be compact. 1.1. What is the ratio of the Value added (current US$) of Agriculture in 1983 to that in 1985?
Your answer should be compact. 0.73. What is the ratio of the Value added (current US$) in Industry in 1984 to that in 1985?
Make the answer very short. 1.28. What is the ratio of the Value added (current US$) in Manufacturing in 1984 to that in 1985?
Offer a very short reply. 1.12. What is the ratio of the Value added (current US$) of Services in 1984 to that in 1985?
Provide a succinct answer. 1.07. What is the ratio of the Value added (current US$) in Agriculture in 1984 to that in 1985?
Make the answer very short. 0.87. What is the difference between the highest and the second highest Value added (current US$) in Industry?
Your answer should be very brief. 1.28e+1. What is the difference between the highest and the second highest Value added (current US$) of Manufacturing?
Keep it short and to the point. 3.60e+08. What is the difference between the highest and the second highest Value added (current US$) in Services?
Offer a very short reply. 1.36e+09. What is the difference between the highest and the second highest Value added (current US$) of Agriculture?
Ensure brevity in your answer.  5.10e+08. What is the difference between the highest and the lowest Value added (current US$) of Industry?
Your answer should be very brief. 8.73e+1. What is the difference between the highest and the lowest Value added (current US$) in Manufacturing?
Your answer should be very brief. 3.60e+09. What is the difference between the highest and the lowest Value added (current US$) of Services?
Your response must be concise. 2.46e+1. What is the difference between the highest and the lowest Value added (current US$) in Agriculture?
Give a very brief answer. 2.44e+09. 